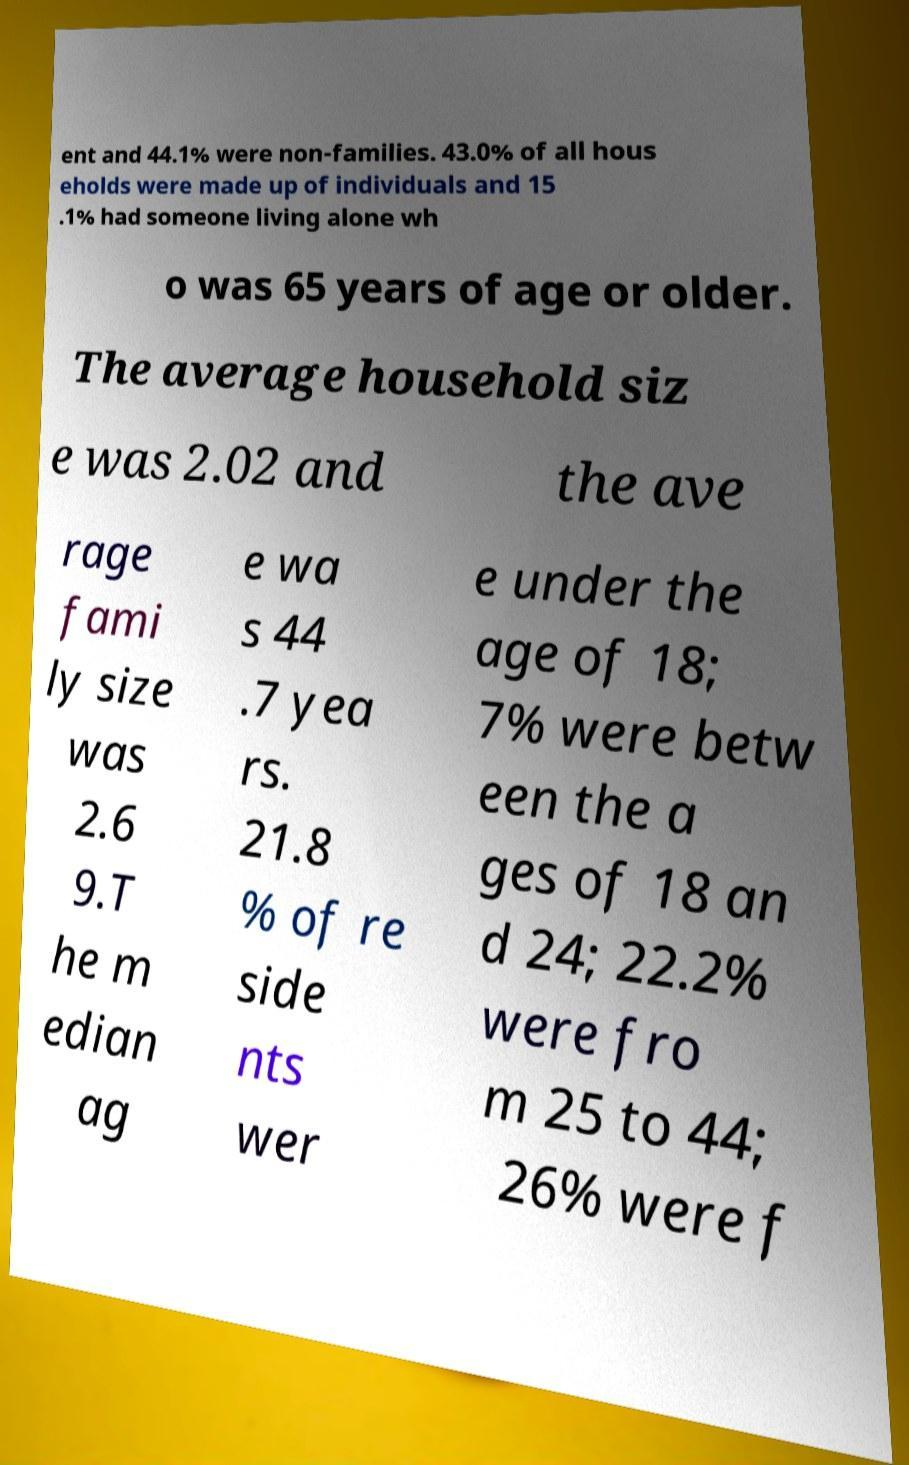There's text embedded in this image that I need extracted. Can you transcribe it verbatim? ent and 44.1% were non-families. 43.0% of all hous eholds were made up of individuals and 15 .1% had someone living alone wh o was 65 years of age or older. The average household siz e was 2.02 and the ave rage fami ly size was 2.6 9.T he m edian ag e wa s 44 .7 yea rs. 21.8 % of re side nts wer e under the age of 18; 7% were betw een the a ges of 18 an d 24; 22.2% were fro m 25 to 44; 26% were f 